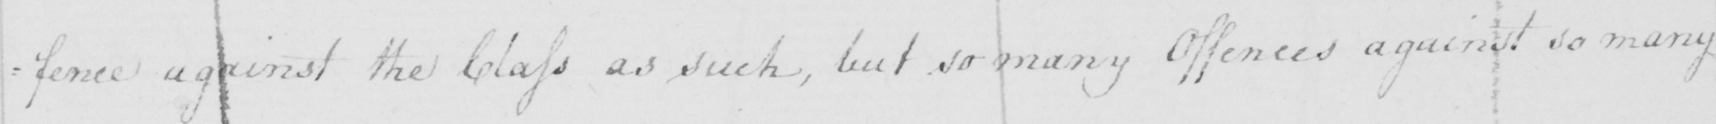Please transcribe the handwritten text in this image. : fence against the Class as such , but so many Offences against so many 